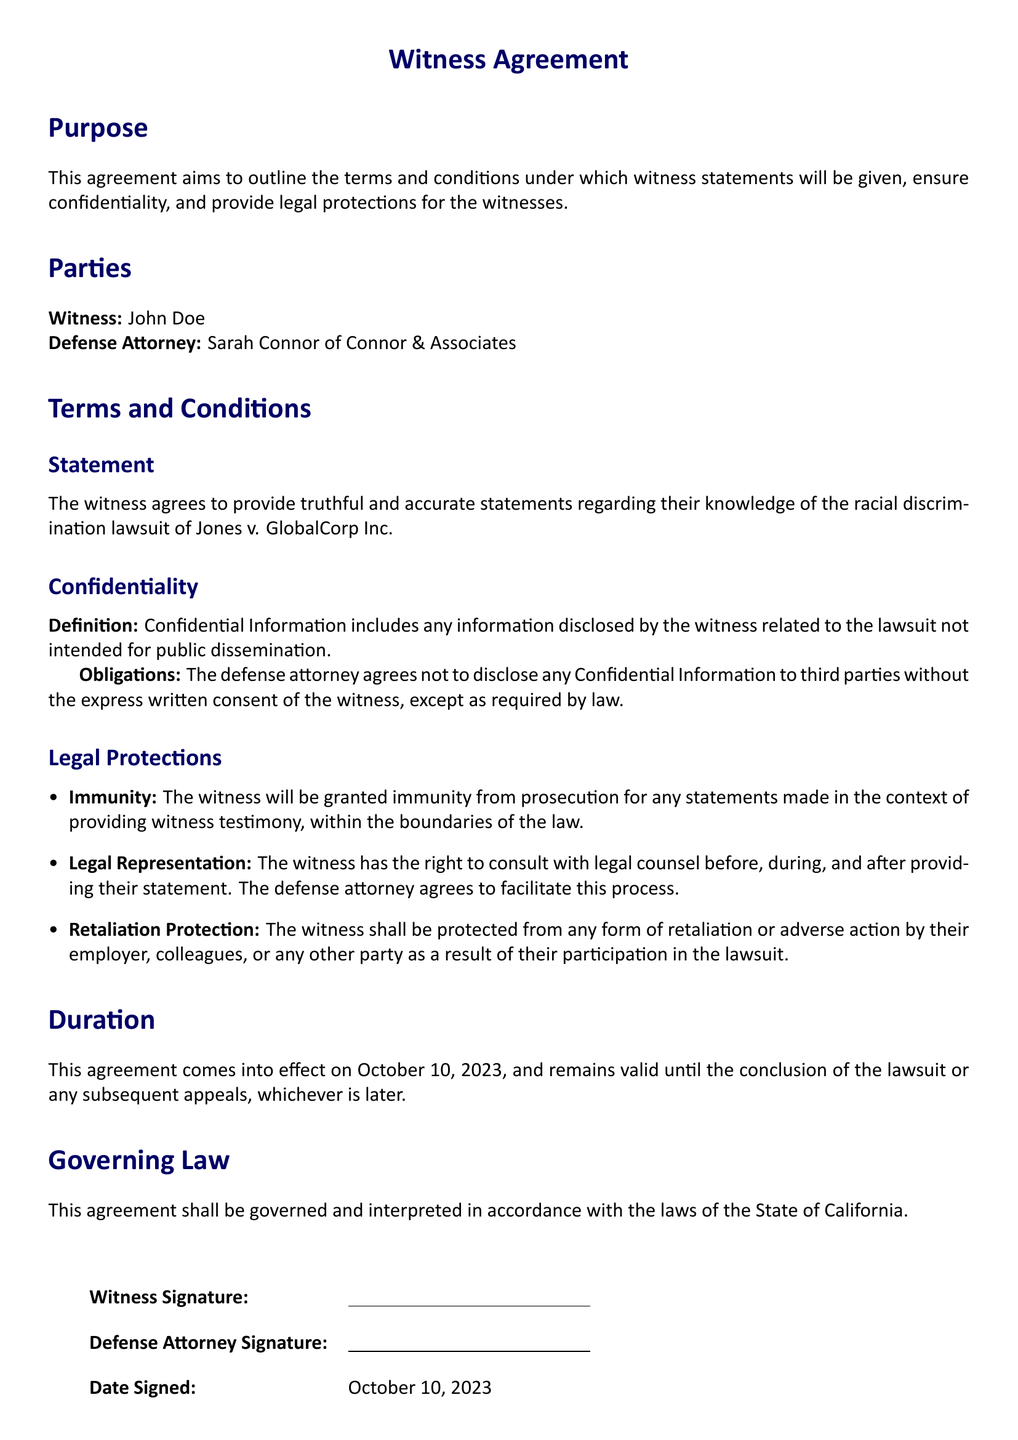What is the name of the witness? The document explicitly mentions the name of the witness as John Doe.
Answer: John Doe Who is the defense attorney? The defense attorney's name is clearly stated in the document as Sarah Connor of Connor & Associates.
Answer: Sarah Connor What is the effective date of the agreement? The agreement specifies that it comes into effect on October 10, 2023.
Answer: October 10, 2023 What does Confidential Information refer to in this document? The document defines Confidential Information as information related to the lawsuit not intended for public dissemination.
Answer: Information related to the lawsuit not intended for public dissemination What type of immunity is granted to the witness? The witness is granted immunity from prosecution for statements made during the witness testimony.
Answer: Immunity from prosecution What is the duration of the agreement? The agreement remains valid until the conclusion of the lawsuit or any subsequent appeals, whichever is later.
Answer: Until the conclusion of the lawsuit or any subsequent appeals Is legal representation guaranteed for the witness? The agreement confirms that the witness has the right to consult with legal counsel before, during, and after providing their statement.
Answer: Yes What protection is offered against retaliation? The document states that the witness shall be protected from any form of retaliation or adverse action.
Answer: Protection from retaliation 